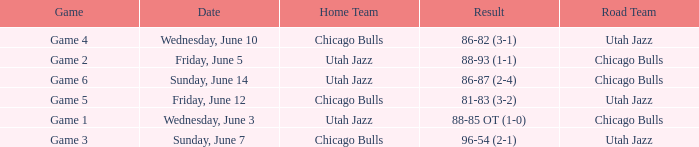Game of game 5 had what result? 81-83 (3-2). 